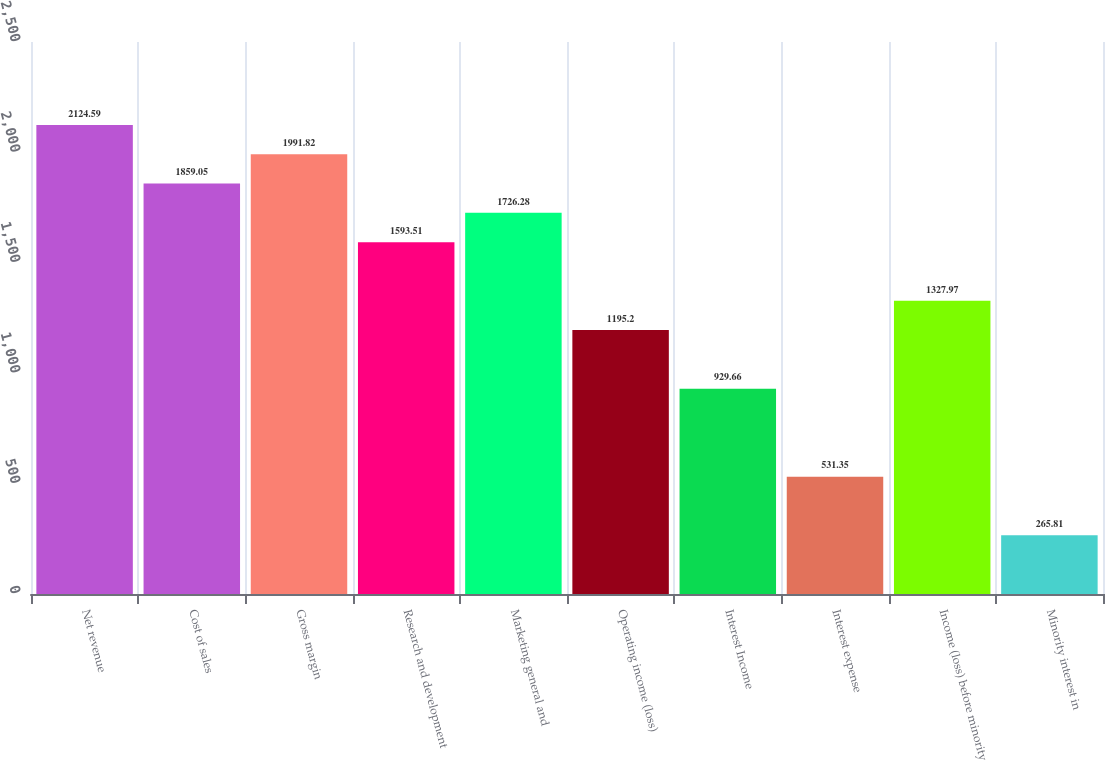Convert chart to OTSL. <chart><loc_0><loc_0><loc_500><loc_500><bar_chart><fcel>Net revenue<fcel>Cost of sales<fcel>Gross margin<fcel>Research and development<fcel>Marketing general and<fcel>Operating income (loss)<fcel>Interest Income<fcel>Interest expense<fcel>Income (loss) before minority<fcel>Minority interest in<nl><fcel>2124.59<fcel>1859.05<fcel>1991.82<fcel>1593.51<fcel>1726.28<fcel>1195.2<fcel>929.66<fcel>531.35<fcel>1327.97<fcel>265.81<nl></chart> 